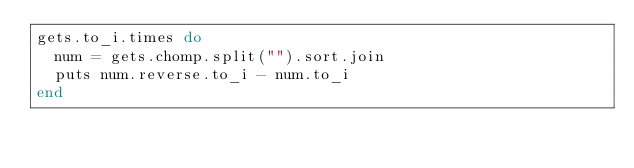<code> <loc_0><loc_0><loc_500><loc_500><_Ruby_>gets.to_i.times do
	num = gets.chomp.split("").sort.join
	puts num.reverse.to_i - num.to_i
end</code> 